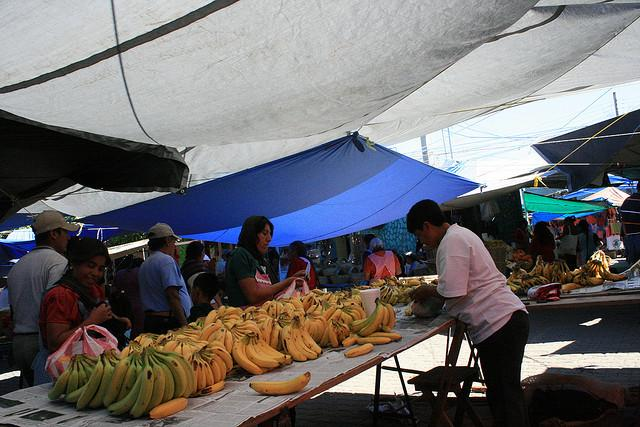Encouraging what American Ice cream treat is an obvious choice for these vendors? banana split 